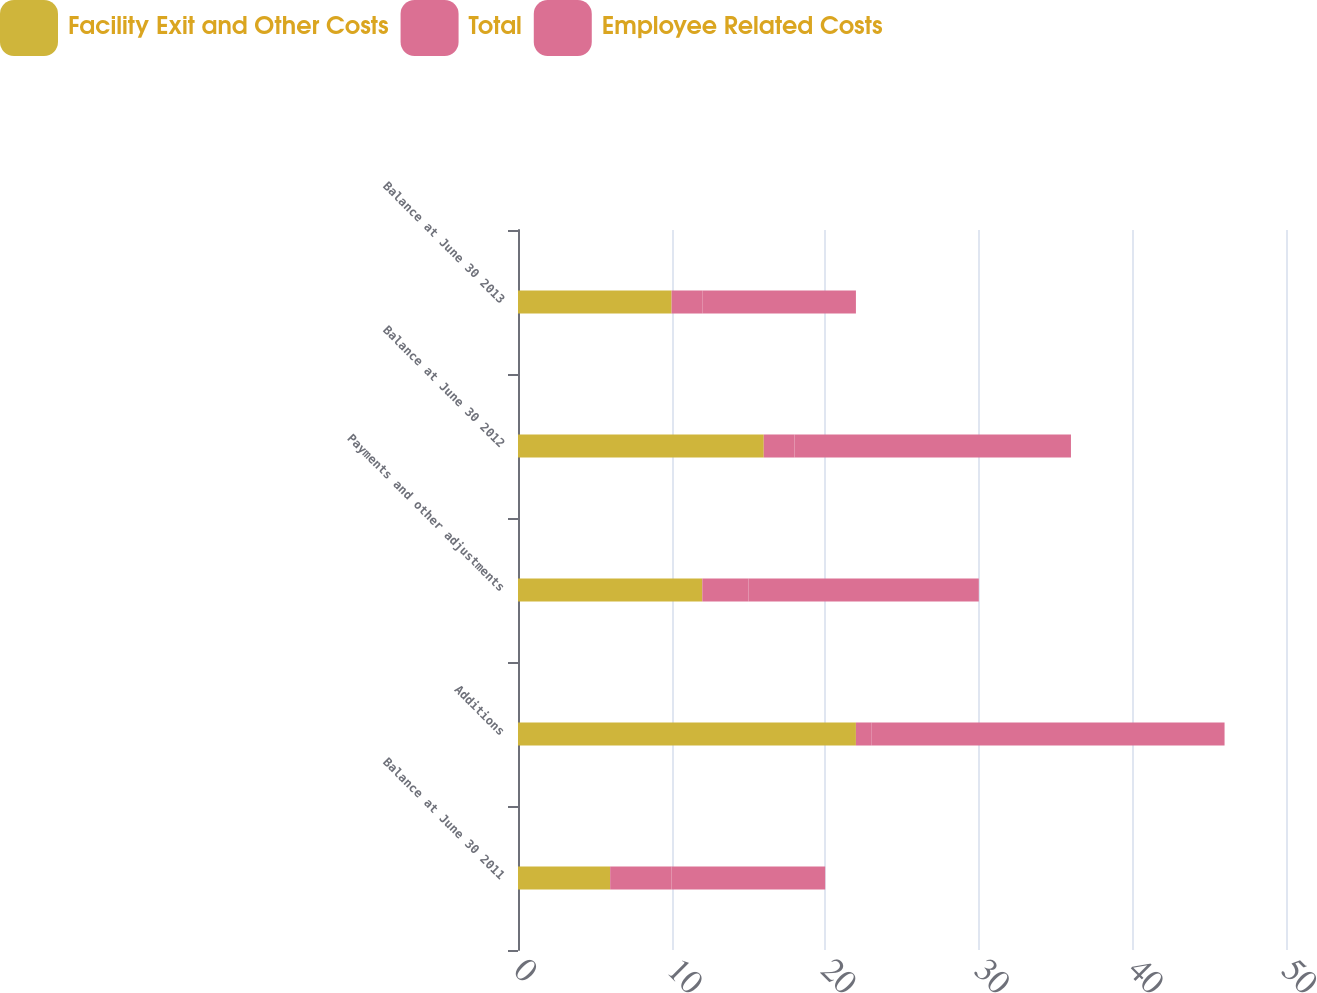Convert chart. <chart><loc_0><loc_0><loc_500><loc_500><stacked_bar_chart><ecel><fcel>Balance at June 30 2011<fcel>Additions<fcel>Payments and other adjustments<fcel>Balance at June 30 2012<fcel>Balance at June 30 2013<nl><fcel>Facility Exit and Other Costs<fcel>6<fcel>22<fcel>12<fcel>16<fcel>10<nl><fcel>Total<fcel>4<fcel>1<fcel>3<fcel>2<fcel>2<nl><fcel>Employee Related Costs<fcel>10<fcel>23<fcel>15<fcel>18<fcel>10<nl></chart> 